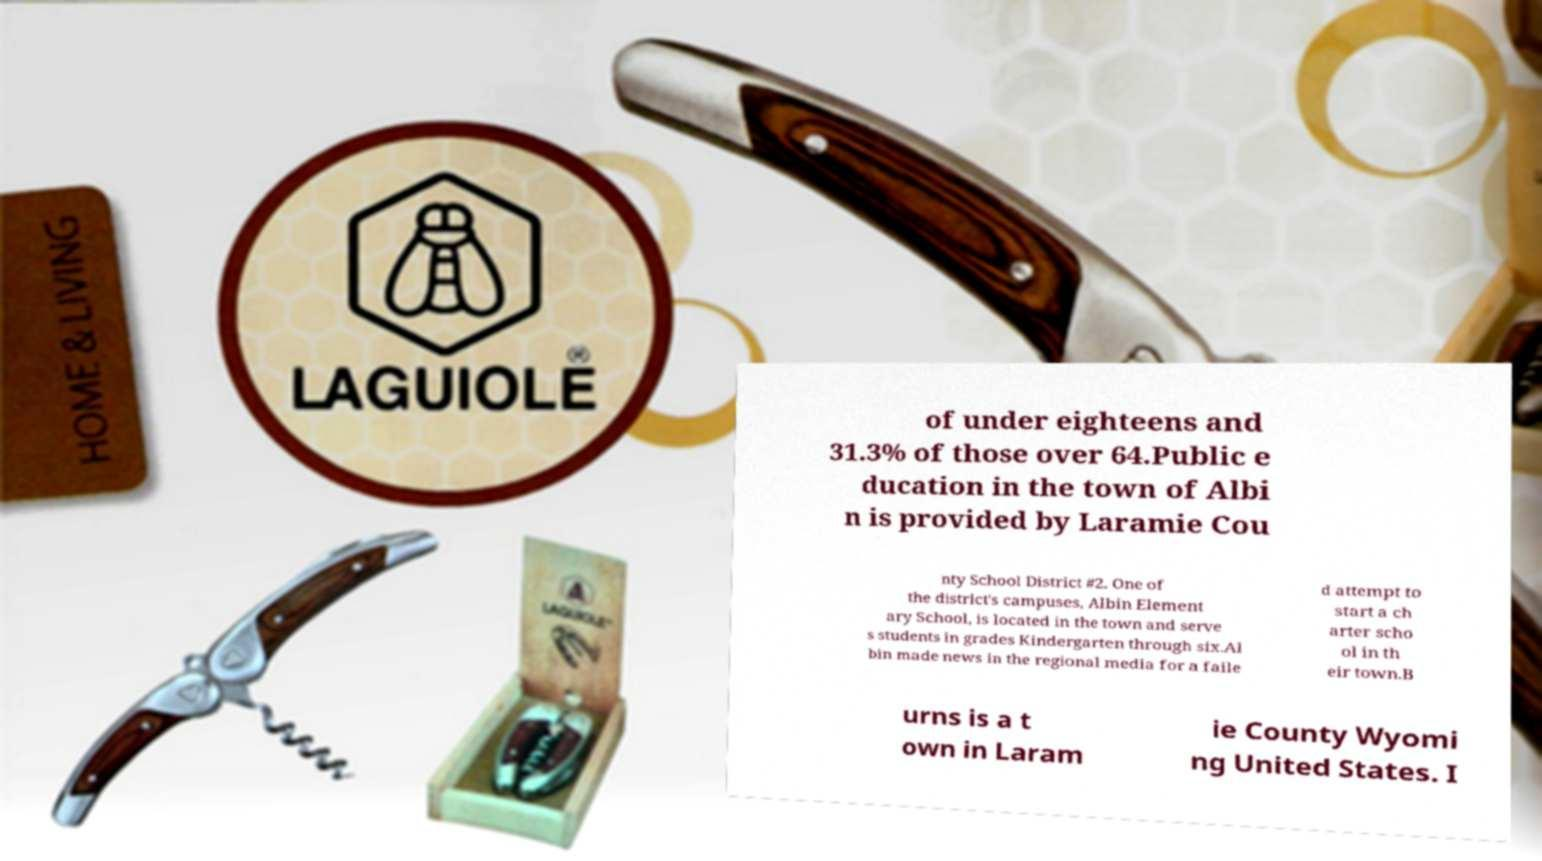Please read and relay the text visible in this image. What does it say? of under eighteens and 31.3% of those over 64.Public e ducation in the town of Albi n is provided by Laramie Cou nty School District #2. One of the district's campuses, Albin Element ary School, is located in the town and serve s students in grades Kindergarten through six.Al bin made news in the regional media for a faile d attempt to start a ch arter scho ol in th eir town.B urns is a t own in Laram ie County Wyomi ng United States. I 